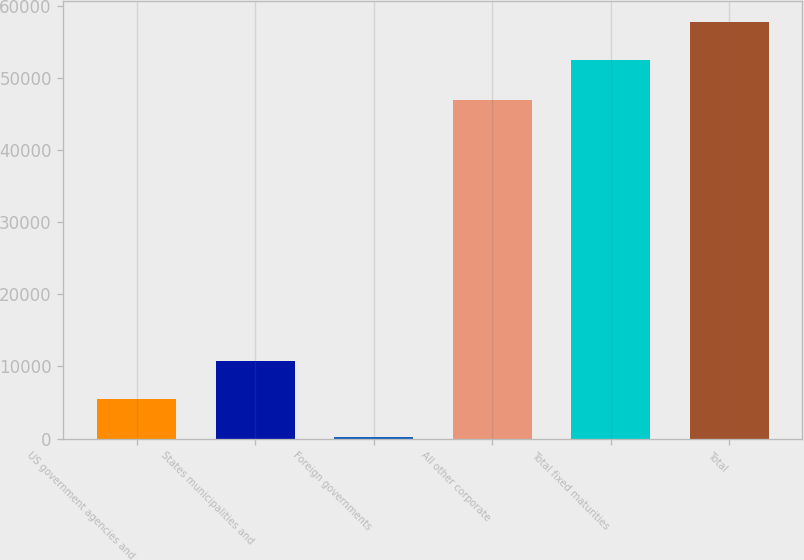Convert chart. <chart><loc_0><loc_0><loc_500><loc_500><bar_chart><fcel>US government agencies and<fcel>States municipalities and<fcel>Foreign governments<fcel>All other corporate<fcel>Total fixed maturities<fcel>Total<nl><fcel>5464.7<fcel>10694.4<fcel>235<fcel>46956<fcel>52532<fcel>57761.7<nl></chart> 